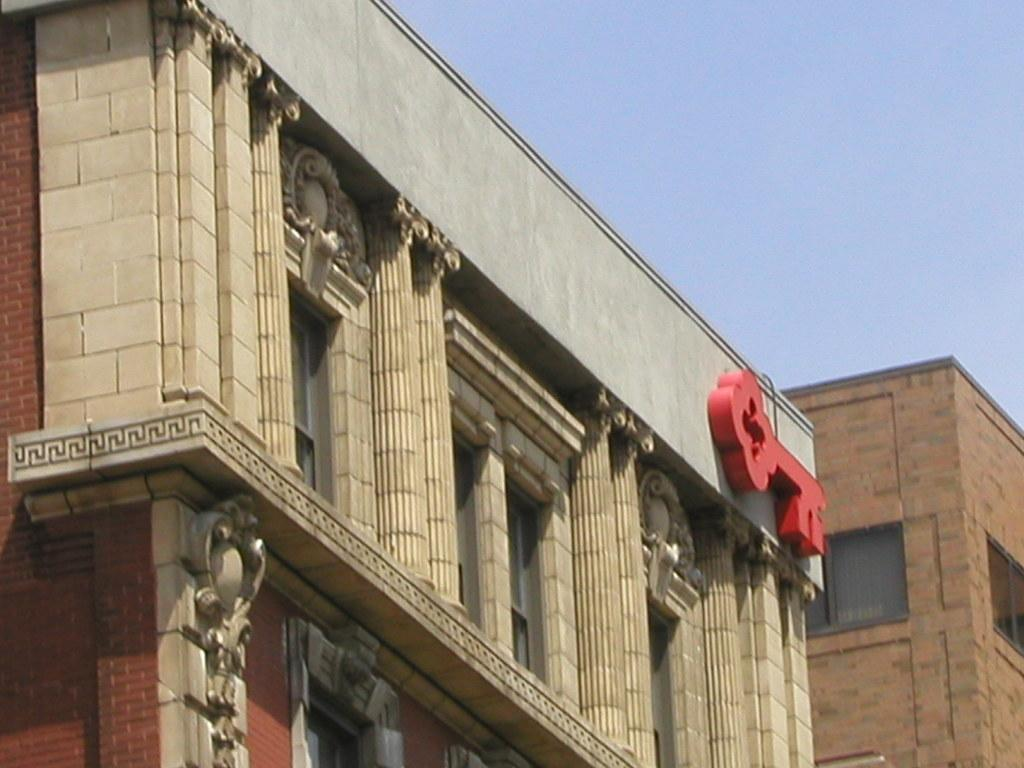What type of structures can be seen in the image? There are buildings in the image. What feature is visible on the buildings? There are windows visible in the image. What is visible at the top of the image? The sky is visible at the top of the image. When was the image taken? The image was taken during the day. Can you see a group of people skating on the windows in the image? There is no group of people skating on the windows in the image; the windows are part of the buildings and are not being used for skating. 